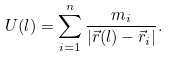<formula> <loc_0><loc_0><loc_500><loc_500>U ( l ) = \sum _ { i = 1 } ^ { n } \frac { m _ { i } } { | \vec { r } ( l ) - \vec { r } _ { i } | } .</formula> 